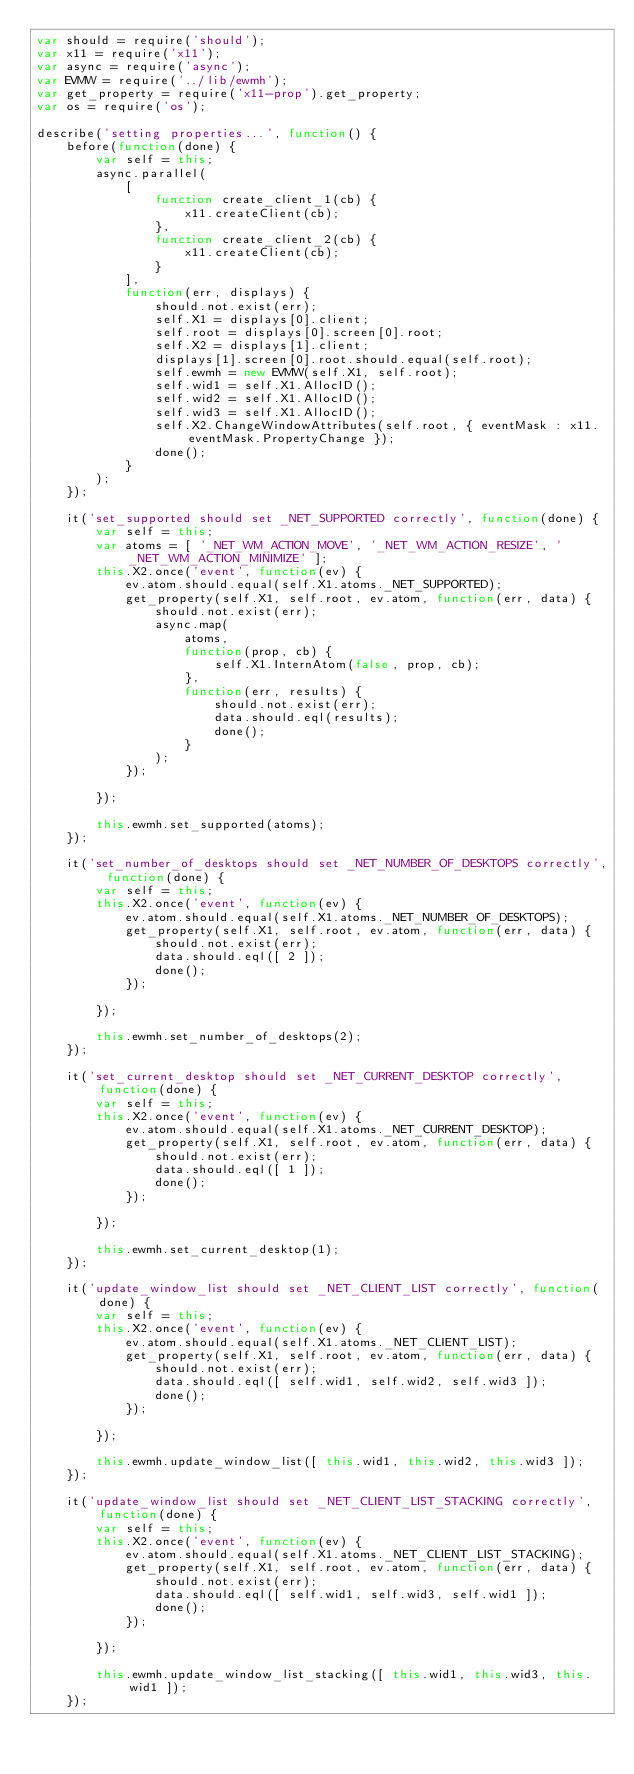<code> <loc_0><loc_0><loc_500><loc_500><_JavaScript_>var should = require('should');
var x11 = require('x11');
var async = require('async');
var EVMW = require('../lib/ewmh');
var get_property = require('x11-prop').get_property;
var os = require('os');

describe('setting properties...', function() {
    before(function(done) {
        var self = this;
        async.parallel(
            [
                function create_client_1(cb) {
                    x11.createClient(cb);
                },
                function create_client_2(cb) {
                    x11.createClient(cb);
                }
            ],
            function(err, displays) {
                should.not.exist(err);
                self.X1 = displays[0].client;
                self.root = displays[0].screen[0].root;
                self.X2 = displays[1].client;
                displays[1].screen[0].root.should.equal(self.root);
                self.ewmh = new EVMW(self.X1, self.root);
                self.wid1 = self.X1.AllocID();
                self.wid2 = self.X1.AllocID();
                self.wid3 = self.X1.AllocID();
                self.X2.ChangeWindowAttributes(self.root, { eventMask : x11.eventMask.PropertyChange });
                done();
            }
        );
    });

    it('set_supported should set _NET_SUPPORTED correctly', function(done) {
        var self = this;
        var atoms = [ '_NET_WM_ACTION_MOVE', '_NET_WM_ACTION_RESIZE', '_NET_WM_ACTION_MINIMIZE' ];
        this.X2.once('event', function(ev) {
            ev.atom.should.equal(self.X1.atoms._NET_SUPPORTED);
            get_property(self.X1, self.root, ev.atom, function(err, data) {
                should.not.exist(err);
                async.map(
                    atoms,
                    function(prop, cb) {
                        self.X1.InternAtom(false, prop, cb);
                    },
                    function(err, results) {
                        should.not.exist(err);
                        data.should.eql(results);
                        done();
                    }
                );
            });

        });

        this.ewmh.set_supported(atoms);
    });

    it('set_number_of_desktops should set _NET_NUMBER_OF_DESKTOPS correctly', function(done) {
        var self = this;
        this.X2.once('event', function(ev) {
            ev.atom.should.equal(self.X1.atoms._NET_NUMBER_OF_DESKTOPS);
            get_property(self.X1, self.root, ev.atom, function(err, data) {
                should.not.exist(err);
                data.should.eql([ 2 ]);
                done();
            });

        });

        this.ewmh.set_number_of_desktops(2);
    });

    it('set_current_desktop should set _NET_CURRENT_DESKTOP correctly', function(done) {
        var self = this;
        this.X2.once('event', function(ev) {
            ev.atom.should.equal(self.X1.atoms._NET_CURRENT_DESKTOP);
            get_property(self.X1, self.root, ev.atom, function(err, data) {
                should.not.exist(err);
                data.should.eql([ 1 ]);
                done();
            });

        });

        this.ewmh.set_current_desktop(1);
    });

    it('update_window_list should set _NET_CLIENT_LIST correctly', function(done) {
        var self = this;
        this.X2.once('event', function(ev) {
            ev.atom.should.equal(self.X1.atoms._NET_CLIENT_LIST);
            get_property(self.X1, self.root, ev.atom, function(err, data) {
                should.not.exist(err);
                data.should.eql([ self.wid1, self.wid2, self.wid3 ]);
                done();
            });

        });

        this.ewmh.update_window_list([ this.wid1, this.wid2, this.wid3 ]);
    });

    it('update_window_list should set _NET_CLIENT_LIST_STACKING correctly', function(done) {
        var self = this;
        this.X2.once('event', function(ev) {
            ev.atom.should.equal(self.X1.atoms._NET_CLIENT_LIST_STACKING);
            get_property(self.X1, self.root, ev.atom, function(err, data) {
                should.not.exist(err);
                data.should.eql([ self.wid1, self.wid3, self.wid1 ]);
                done();
            });

        });

        this.ewmh.update_window_list_stacking([ this.wid1, this.wid3, this.wid1 ]);
    });
</code> 